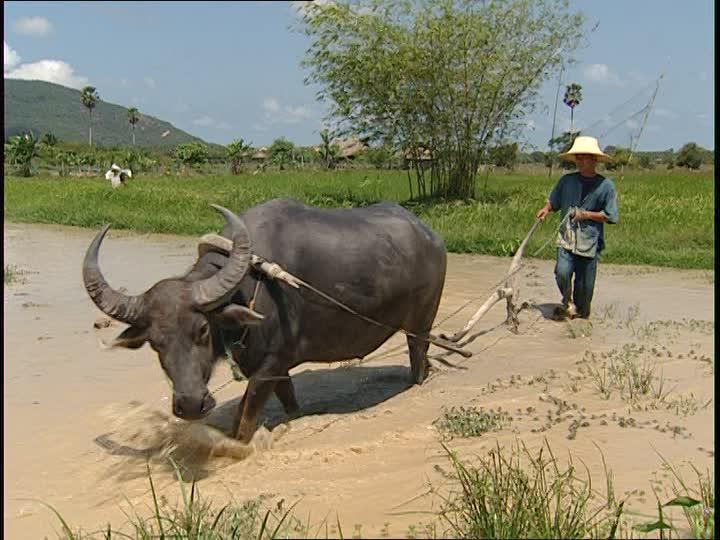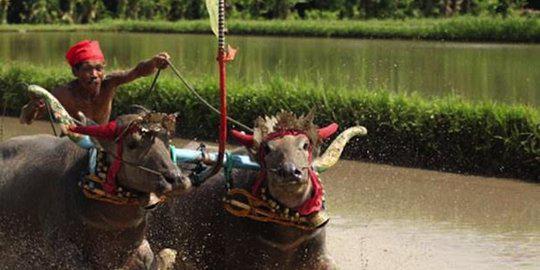The first image is the image on the left, the second image is the image on the right. Assess this claim about the two images: "One image shows a man holding a gun posed next to a dead water buffalo, and the other image shows at least one person riding on the back of a water buffalo.". Correct or not? Answer yes or no. No. The first image is the image on the left, the second image is the image on the right. Considering the images on both sides, is "The left image contains one hunter near one dead water buffalo." valid? Answer yes or no. No. 